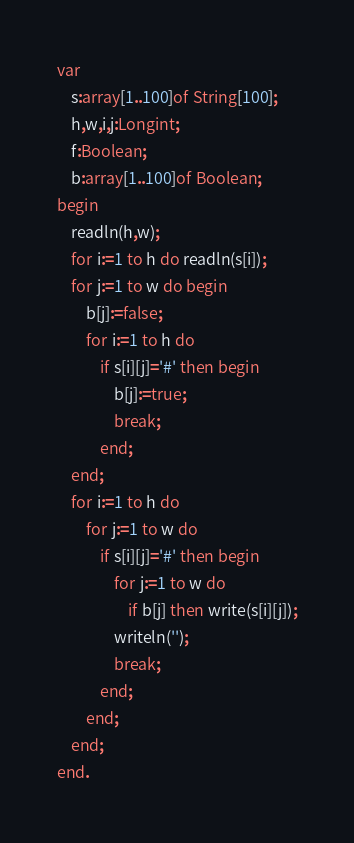<code> <loc_0><loc_0><loc_500><loc_500><_Pascal_>var
	s:array[1..100]of String[100];
	h,w,i,j:Longint;
	f:Boolean;
	b:array[1..100]of Boolean;
begin
	readln(h,w);
	for i:=1 to h do readln(s[i]);
	for j:=1 to w do begin
		b[j]:=false;
		for i:=1 to h do
			if s[i][j]='#' then begin
				b[j]:=true;
				break;
			end;
	end;
	for i:=1 to h do
		for j:=1 to w do
			if s[i][j]='#' then begin
				for j:=1 to w do
					if b[j] then write(s[i][j]);
				writeln('');
                break;
            end;
		end;
	end;
end.
</code> 